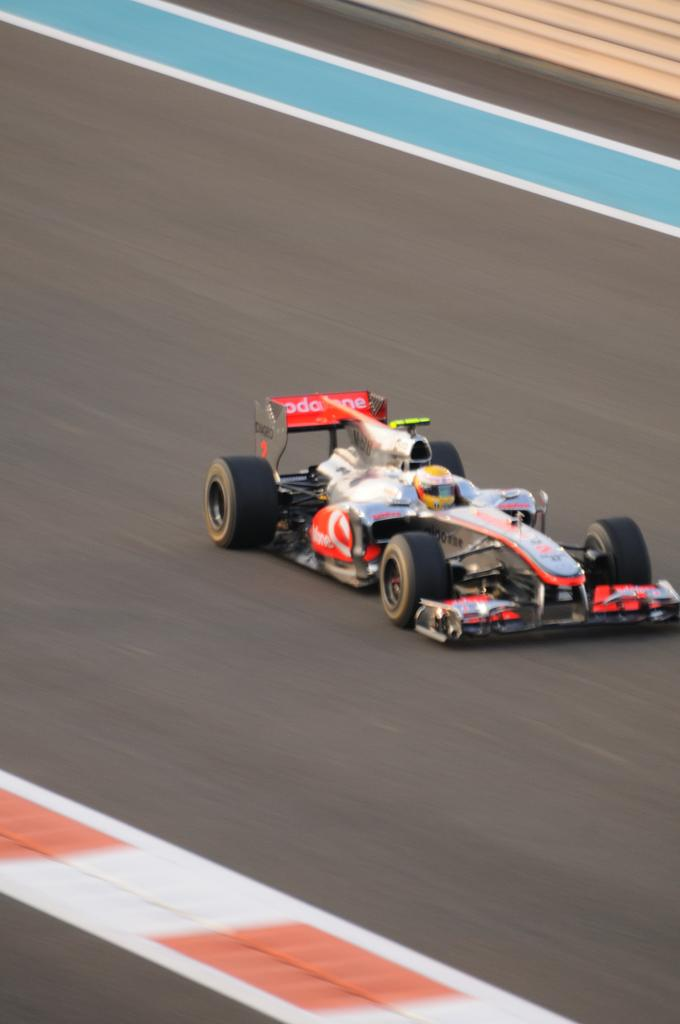What is the main subject of the image? There is a person driving a sports car in the image. Where is the car located? The car is on the road. What time of day does the image appear to be taken? The image appears to be taken during the day. From what perspective was the image taken? The image may have been taken from the ground. What type of branch can be seen growing from the car in the image? There is no branch growing from the car in the image. How many beetles are crawling on the person driving the car in the image? There are no beetles present in the image. 